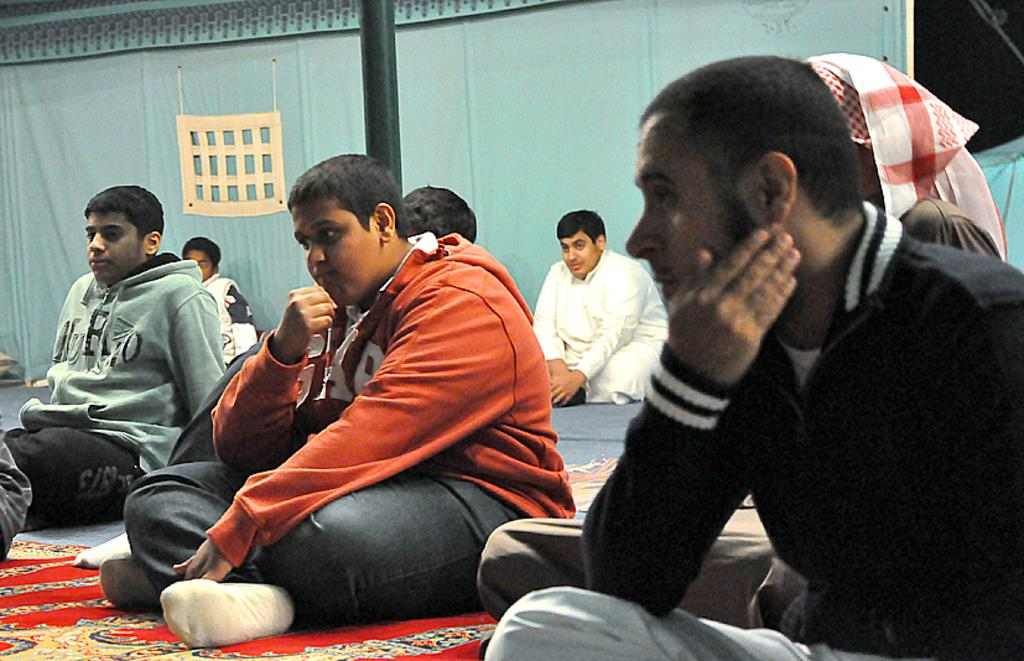What is the main activity of the people in the image? There are many people sitting in the image, but the specific activity is not mentioned in the facts. What is on the floor in the image? There is a floor mat on the floor. What type of fabric is visible in the image? There is a cloth visible in the image. What is the tall, vertical object in the image? There is a pole in the image. What type of trousers are the people wearing in the image? The facts provided do not mention the type of clothing the people are wearing, so we cannot determine the type of trousers. What kind of music is being played in the image? There is no mention of music in the facts provided, so we cannot determine if any music is being played. 